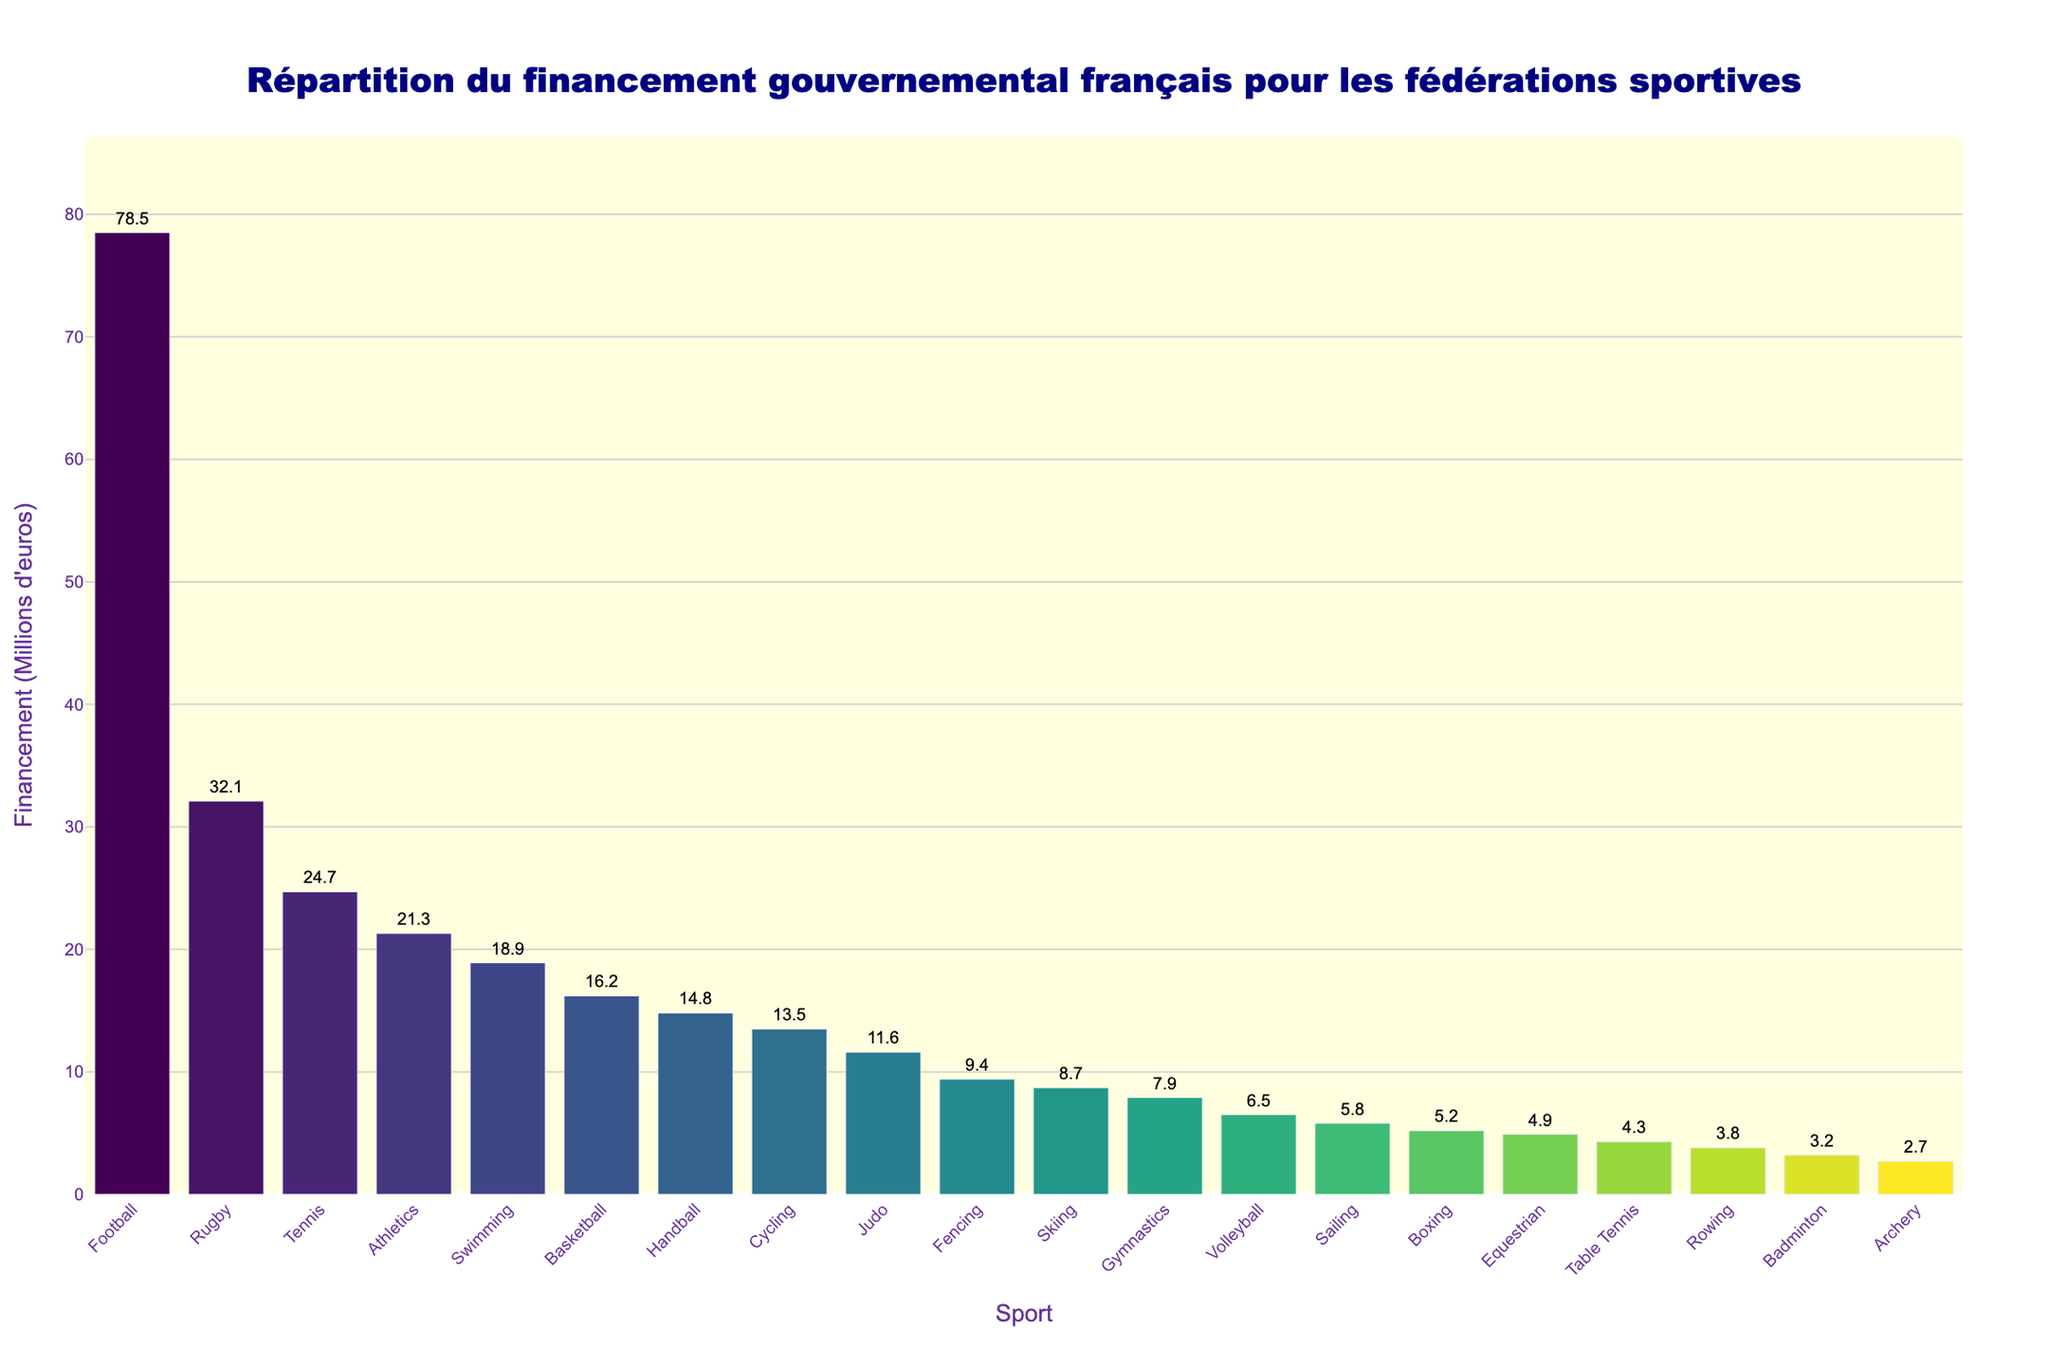Quels sont les trois sports ayant reçu le plus de financement? En observant le graphique, les trois barres les plus hautes représentent le football, le rugby et le tennis, ce qui signifie qu'ils ont reçu le plus de financement.
Answer: Football, rugby, tennis Quel sport a reçu moins de 5 millions d'euros de financement? La catégorie « Archery » montre une barre plus basse avec une étiquette de 2,7 millions d'euros, ce qui est inférieur à 5 millions d'euros.
Answer: Archery Quel est le financement total des sports de basket-ball, handball et voile? Additionnons les financements pour le basket-ball (16.2), le handball (14.8) et la voile (5.8): 16.2 + 14.8 + 5.8 = 36.8 millions d'euros.
Answer: 36.8 millions d'euros Quel sport, entre le vélo et la gymnastique, a reçu plus de financement? En comparant les barres de ces deux sports, la barre du vélo (13.5) est plus haute que celle de la gymnastique (7.9), indiquant un financement plus élevé.
Answer: Vélo Combien de sports ont reçu un financement supérieur à 20 millions d'euros? Les sports avec des barres plus hautes et des étiquettes indiquant des financements supérieurs à 20 millions d'euros sont le football, le rugby, le tennis et l'athlétisme. Il y en a 4.
Answer: Quatre Quel sport a reçu le montant de financement le plus proche de 10 millions d'euros? La barre correspondant au judo affiche un montant de 11.6 millions d'euros, qui est le plus proche de 10 millions.
Answer: Judo Quel est le sport ayant reçu le moins de financement et quel est ce montant? La barre la plus basse correspond à l'archery avec un financement de 2.7 millions d'euros.
Answer: Archery, 2.7 millions d'euros Par combien le financement du football surpasse-t-il celui du cyclisme? Soustrayons le financement du cyclisme (13.5) de celui du football (78.5): 78.5 - 13.5 = 65 millions d'euros.
Answer: 65 millions d'euros Quel est le financement moyen des sports listés? Additionnons tous les financements et divisons par le nombre total de sports (20). 78.5 + 32.1 + 24.7 + 21.3 + 18.9 + 16.2 + 14.8 + 13.5 + 11.6 + 9.4 + 8.7 + 7.9 + 6.5 + 5.8 + 5.2 + 4.9 + 4.3 + 3.8 + 3.2 + 2.7 = 313.1 millions d'euros. Moyenne = 313.1 / 20 = 15.65 millions d'euros.
Answer: 15.65 millions d'euros 